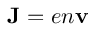Convert formula to latex. <formula><loc_0><loc_0><loc_500><loc_500>{ J } = e n { v }</formula> 